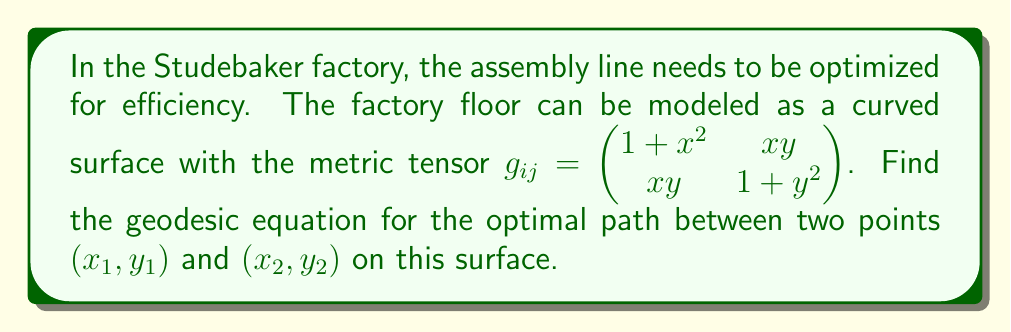What is the answer to this math problem? To find the geodesic equation, we'll follow these steps:

1) First, we need to calculate the Christoffel symbols using the metric tensor:
   $$\Gamma^k_{ij} = \frac{1}{2}g^{kl}(\partial_i g_{jl} + \partial_j g_{il} - \partial_l g_{ij})$$

2) The inverse metric tensor is:
   $$g^{ij} = \frac{1}{(1+x^2)(1+y^2)-x^2y^2} \begin{pmatrix} 1+y^2 & -xy \\ -xy & 1+x^2 \end{pmatrix}$$

3) Calculating the non-zero Christoffel symbols:
   $$\Gamma^1_{11} = \frac{x(1+y^2)}{(1+x^2)(1+y^2)-x^2y^2}$$
   $$\Gamma^1_{12} = \Gamma^1_{21} = \frac{y(1+y^2)}{(1+x^2)(1+y^2)-x^2y^2}$$
   $$\Gamma^2_{11} = -\frac{xy}{(1+x^2)(1+y^2)-x^2y^2}$$
   $$\Gamma^2_{12} = \Gamma^2_{21} = \frac{x(1+x^2)}{(1+x^2)(1+y^2)-x^2y^2}$$
   $$\Gamma^2_{22} = \frac{y(1+x^2)}{(1+x^2)(1+y^2)-x^2y^2}$$

4) The geodesic equations are:
   $$\frac{d^2x^i}{dt^2} + \Gamma^i_{jk}\frac{dx^j}{dt}\frac{dx^k}{dt} = 0$$

5) Substituting the Christoffel symbols, we get two coupled differential equations:

   $$\frac{d^2x}{dt^2} + \frac{x(1+y^2)}{(1+x^2)(1+y^2)-x^2y^2}\left(\frac{dx}{dt}\right)^2 + \frac{2y(1+y^2)}{(1+x^2)(1+y^2)-x^2y^2}\frac{dx}{dt}\frac{dy}{dt} = 0$$

   $$\frac{d^2y}{dt^2} - \frac{xy}{(1+x^2)(1+y^2)-x^2y^2}\left(\frac{dx}{dt}\right)^2 + \frac{2x(1+x^2)}{(1+x^2)(1+y^2)-x^2y^2}\frac{dx}{dt}\frac{dy}{dt} + \frac{y(1+x^2)}{(1+x^2)(1+y^2)-x^2y^2}\left(\frac{dy}{dt}\right)^2 = 0$$

These equations describe the geodesic path on the factory floor.
Answer: $$\begin{cases}
\frac{d^2x}{dt^2} + \frac{x(1+y^2)}{(1+x^2)(1+y^2)-x^2y^2}\left(\frac{dx}{dt}\right)^2 + \frac{2y(1+y^2)}{(1+x^2)(1+y^2)-x^2y^2}\frac{dx}{dt}\frac{dy}{dt} = 0 \\
\frac{d^2y}{dt^2} - \frac{xy}{(1+x^2)(1+y^2)-x^2y^2}\left(\frac{dx}{dt}\right)^2 + \frac{2x(1+x^2)}{(1+x^2)(1+y^2)-x^2y^2}\frac{dx}{dt}\frac{dy}{dt} + \frac{y(1+x^2)}{(1+x^2)(1+y^2)-x^2y^2}\left(\frac{dy}{dt}\right)^2 = 0
\end{cases}$$ 